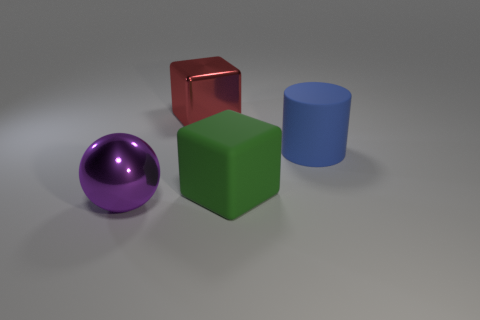Add 2 tiny green shiny cylinders. How many objects exist? 6 Subtract all cylinders. How many objects are left? 3 Subtract all yellow cubes. How many yellow spheres are left? 0 Subtract all green blocks. How many blocks are left? 1 Subtract all matte cylinders. Subtract all red blocks. How many objects are left? 2 Add 3 big red metallic cubes. How many big red metallic cubes are left? 4 Add 1 big purple objects. How many big purple objects exist? 2 Subtract 0 brown blocks. How many objects are left? 4 Subtract all green cylinders. Subtract all yellow cubes. How many cylinders are left? 1 